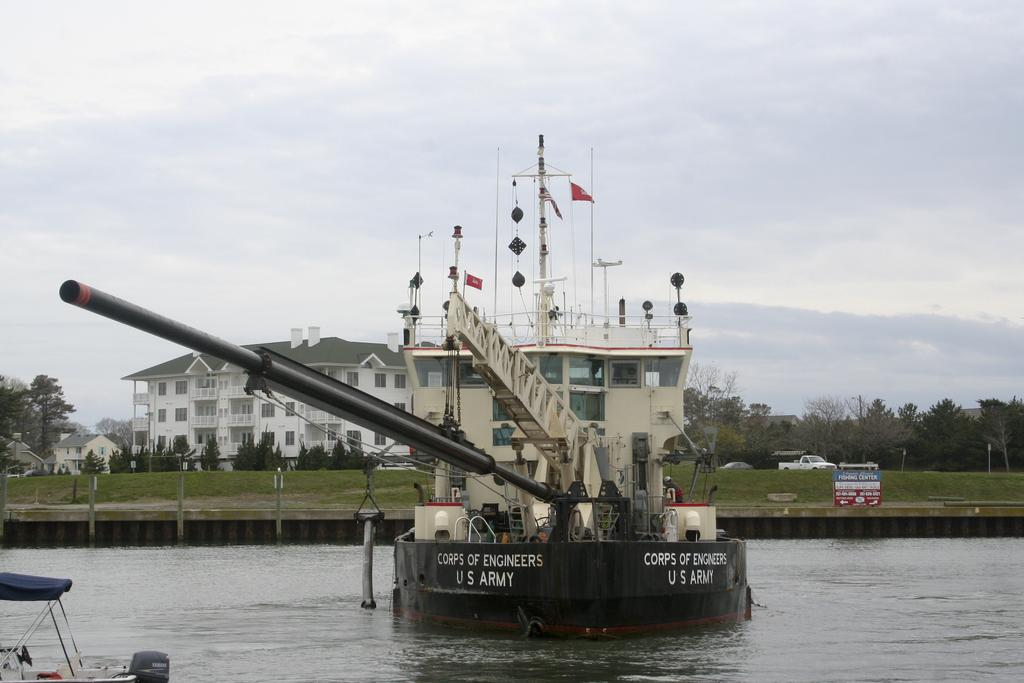What is the main subject of the image? The main subject of the image is a ship on the water. What can be seen in the background of the image? The sky is visible in the background of the image. What type of structures are present in the image? There are buildings in the image. What else is present on the water in the image? There is a boat in the bottom left corner of the image. What other objects can be seen in the image? Vehicles, trees, poles, and a ship are visible in the image. What type of station is depicted in the image? There is no station present in the image. What wish can be granted by looking at the image? The image does not grant wishes, as it is a photograph of a ship, water, and other objects. 